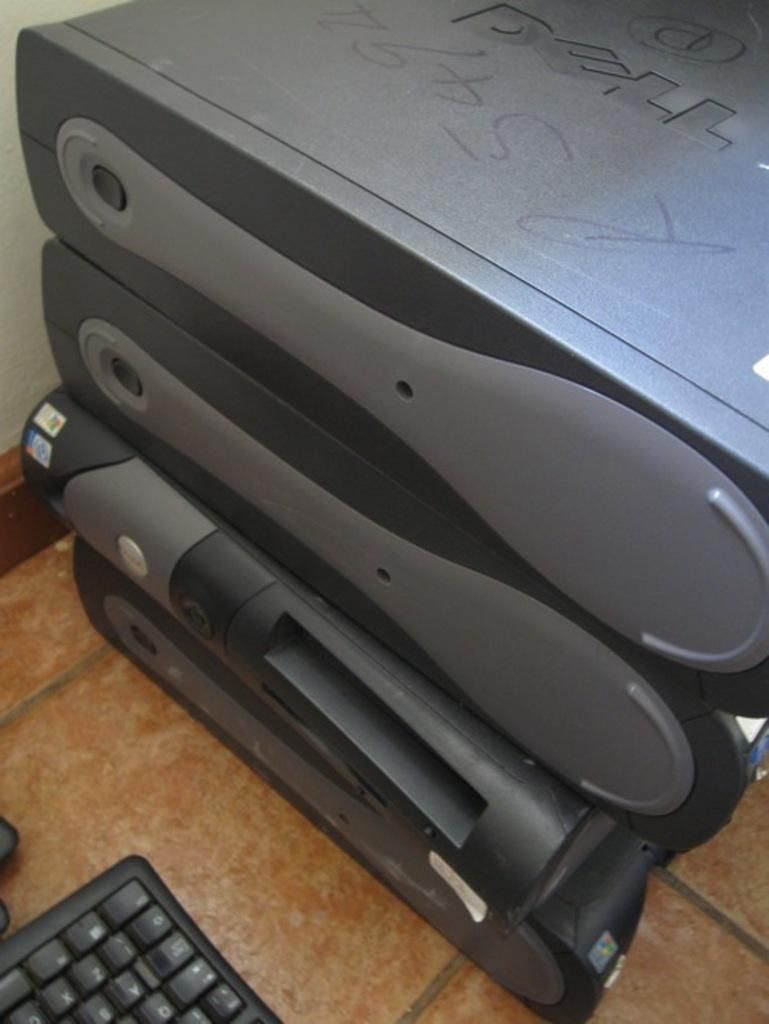<image>
Create a compact narrative representing the image presented. Several computer towers sit on top of each other, with the top one being branded from DELL. 